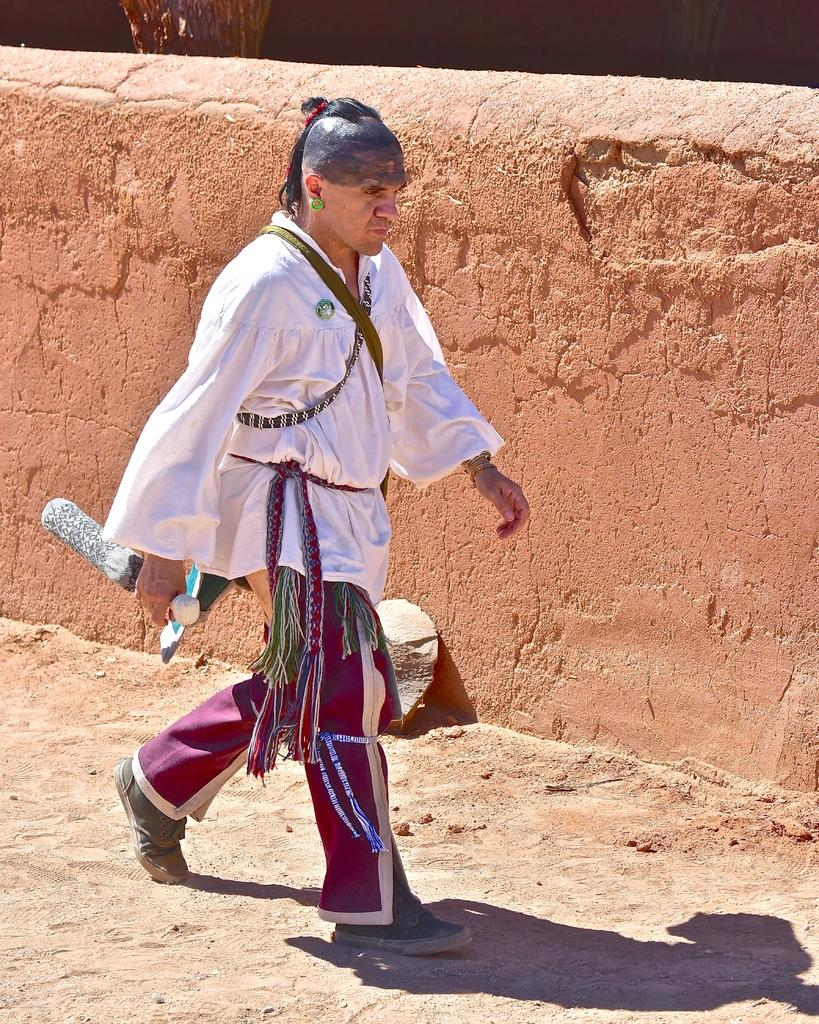What is happening in the image? There is a person in the image, and they are walking. Can you describe the person's clothing? The person is wearing a dress with different colors. What is the person holding in the image? The person is holding something, but we cannot determine what it is from the image. What can be seen in the background of the image? There is a brown color wall and stones visible in the background. What type of system is the person using to answer questions in the image? There is no system visible in the image, and the person is not answering any questions. 